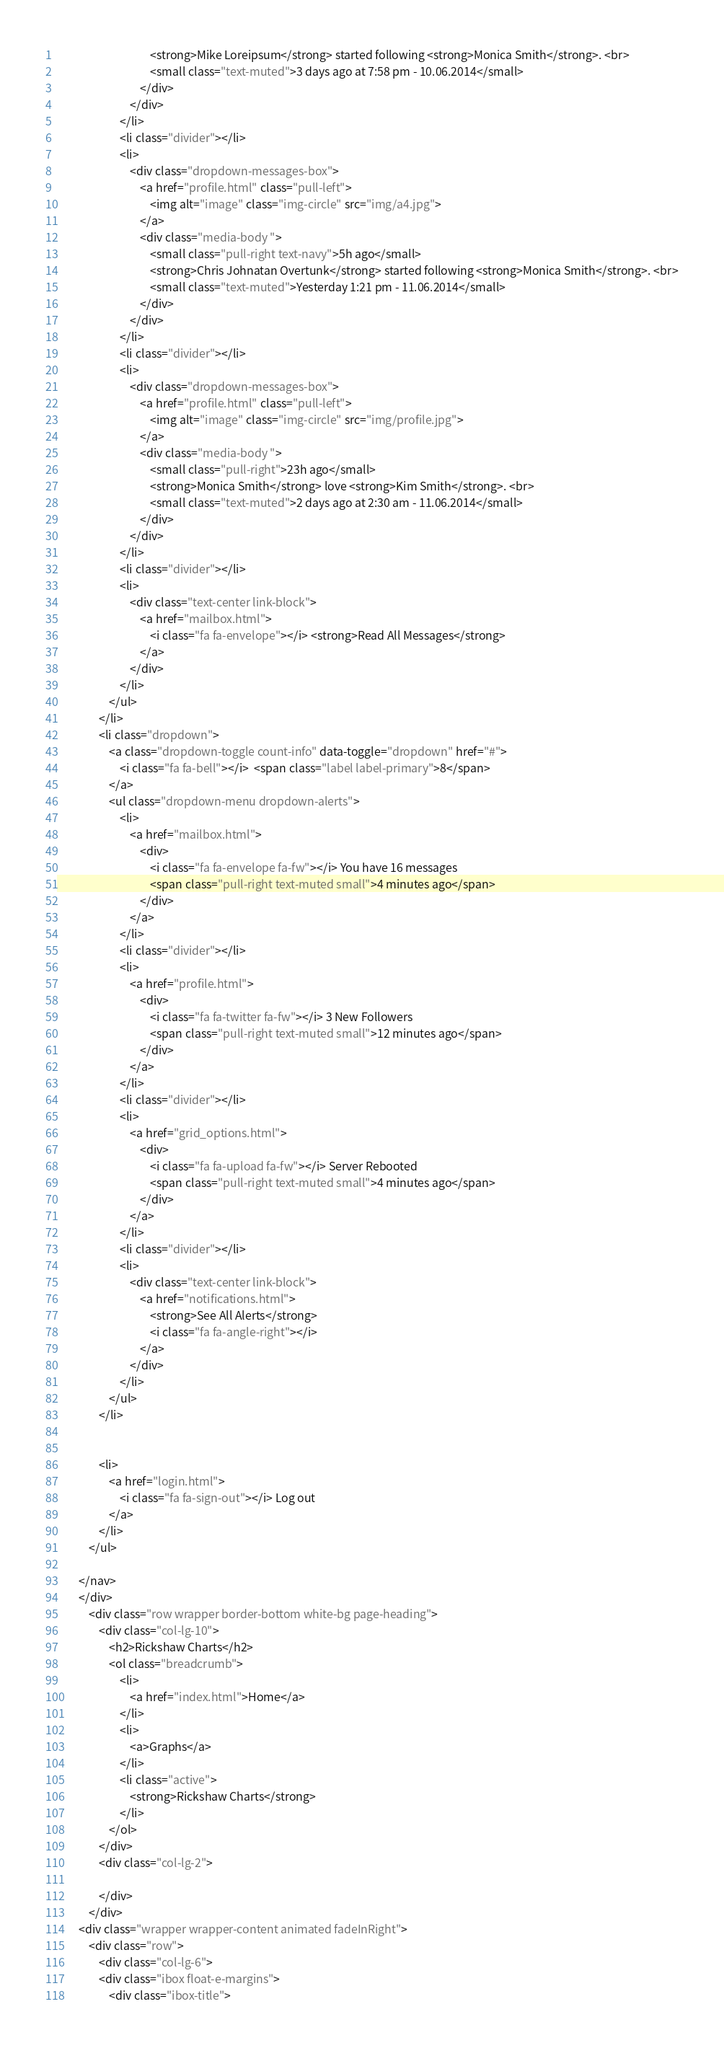Convert code to text. <code><loc_0><loc_0><loc_500><loc_500><_HTML_>                                    <strong>Mike Loreipsum</strong> started following <strong>Monica Smith</strong>. <br>
                                    <small class="text-muted">3 days ago at 7:58 pm - 10.06.2014</small>
                                </div>
                            </div>
                        </li>
                        <li class="divider"></li>
                        <li>
                            <div class="dropdown-messages-box">
                                <a href="profile.html" class="pull-left">
                                    <img alt="image" class="img-circle" src="img/a4.jpg">
                                </a>
                                <div class="media-body ">
                                    <small class="pull-right text-navy">5h ago</small>
                                    <strong>Chris Johnatan Overtunk</strong> started following <strong>Monica Smith</strong>. <br>
                                    <small class="text-muted">Yesterday 1:21 pm - 11.06.2014</small>
                                </div>
                            </div>
                        </li>
                        <li class="divider"></li>
                        <li>
                            <div class="dropdown-messages-box">
                                <a href="profile.html" class="pull-left">
                                    <img alt="image" class="img-circle" src="img/profile.jpg">
                                </a>
                                <div class="media-body ">
                                    <small class="pull-right">23h ago</small>
                                    <strong>Monica Smith</strong> love <strong>Kim Smith</strong>. <br>
                                    <small class="text-muted">2 days ago at 2:30 am - 11.06.2014</small>
                                </div>
                            </div>
                        </li>
                        <li class="divider"></li>
                        <li>
                            <div class="text-center link-block">
                                <a href="mailbox.html">
                                    <i class="fa fa-envelope"></i> <strong>Read All Messages</strong>
                                </a>
                            </div>
                        </li>
                    </ul>
                </li>
                <li class="dropdown">
                    <a class="dropdown-toggle count-info" data-toggle="dropdown" href="#">
                        <i class="fa fa-bell"></i>  <span class="label label-primary">8</span>
                    </a>
                    <ul class="dropdown-menu dropdown-alerts">
                        <li>
                            <a href="mailbox.html">
                                <div>
                                    <i class="fa fa-envelope fa-fw"></i> You have 16 messages
                                    <span class="pull-right text-muted small">4 minutes ago</span>
                                </div>
                            </a>
                        </li>
                        <li class="divider"></li>
                        <li>
                            <a href="profile.html">
                                <div>
                                    <i class="fa fa-twitter fa-fw"></i> 3 New Followers
                                    <span class="pull-right text-muted small">12 minutes ago</span>
                                </div>
                            </a>
                        </li>
                        <li class="divider"></li>
                        <li>
                            <a href="grid_options.html">
                                <div>
                                    <i class="fa fa-upload fa-fw"></i> Server Rebooted
                                    <span class="pull-right text-muted small">4 minutes ago</span>
                                </div>
                            </a>
                        </li>
                        <li class="divider"></li>
                        <li>
                            <div class="text-center link-block">
                                <a href="notifications.html">
                                    <strong>See All Alerts</strong>
                                    <i class="fa fa-angle-right"></i>
                                </a>
                            </div>
                        </li>
                    </ul>
                </li>


                <li>
                    <a href="login.html">
                        <i class="fa fa-sign-out"></i> Log out
                    </a>
                </li>
            </ul>

        </nav>
        </div>
            <div class="row wrapper border-bottom white-bg page-heading">
                <div class="col-lg-10">
                    <h2>Rickshaw Charts</h2>
                    <ol class="breadcrumb">
                        <li>
                            <a href="index.html">Home</a>
                        </li>
                        <li>
                            <a>Graphs</a>
                        </li>
                        <li class="active">
                            <strong>Rickshaw Charts</strong>
                        </li>
                    </ol>
                </div>
                <div class="col-lg-2">

                </div>
            </div>
        <div class="wrapper wrapper-content animated fadeInRight">
            <div class="row">
                <div class="col-lg-6">
                <div class="ibox float-e-margins">
                    <div class="ibox-title"></code> 